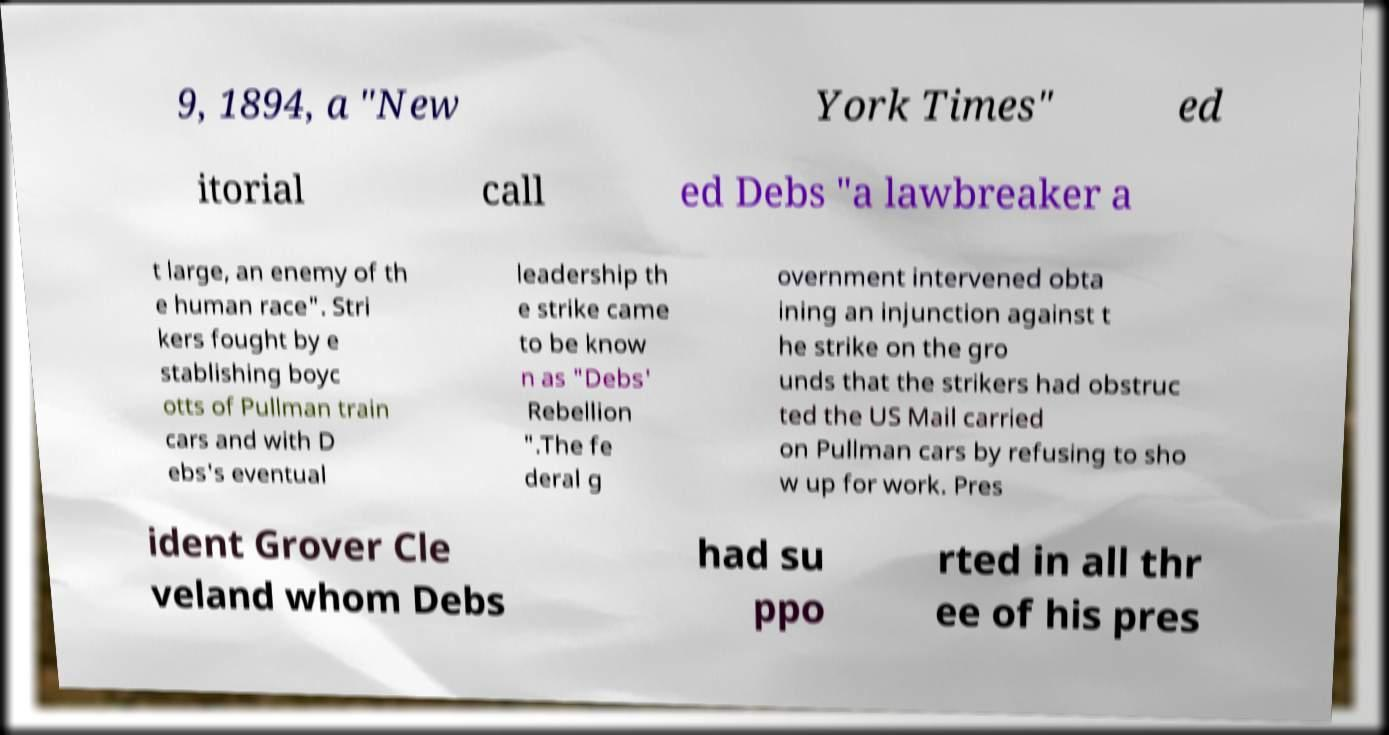I need the written content from this picture converted into text. Can you do that? 9, 1894, a "New York Times" ed itorial call ed Debs "a lawbreaker a t large, an enemy of th e human race". Stri kers fought by e stablishing boyc otts of Pullman train cars and with D ebs's eventual leadership th e strike came to be know n as "Debs' Rebellion ".The fe deral g overnment intervened obta ining an injunction against t he strike on the gro unds that the strikers had obstruc ted the US Mail carried on Pullman cars by refusing to sho w up for work. Pres ident Grover Cle veland whom Debs had su ppo rted in all thr ee of his pres 